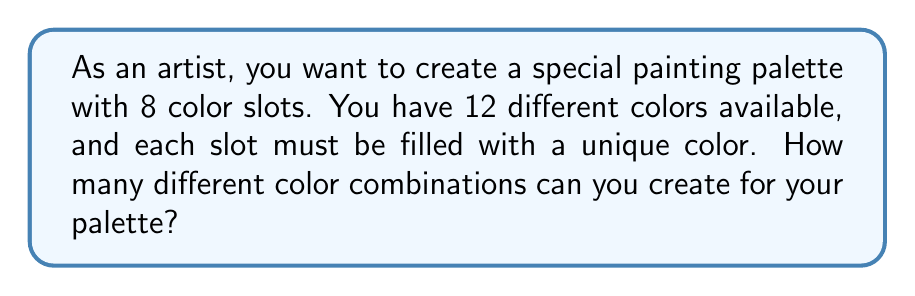Give your solution to this math problem. Let's approach this step-by-step:

1) This is a combination problem where order doesn't matter (we're selecting colors, not arranging them).

2) We're selecting 8 colors out of 12 available colors.

3) In combinatorics, this is denoted as $\binom{12}{8}$ or C(12,8).

4) The formula for this combination is:

   $$\binom{12}{8} = \frac{12!}{8!(12-8)!} = \frac{12!}{8!(4)!}$$

5) Let's calculate this:
   
   $$\frac{12 \times 11 \times 10 \times 9 \times 8!}{8! \times 4 \times 3 \times 2 \times 1}$$

6) The 8! cancels out in the numerator and denominator:

   $$\frac{12 \times 11 \times 10 \times 9}{4 \times 3 \times 2 \times 1}$$

7) Multiply the numerator and denominator:

   $$\frac{11880}{24}$$

8) Divide:

   $$495$$

Therefore, there are 495 different ways to select 8 colors out of 12 for your palette.
Answer: 495 